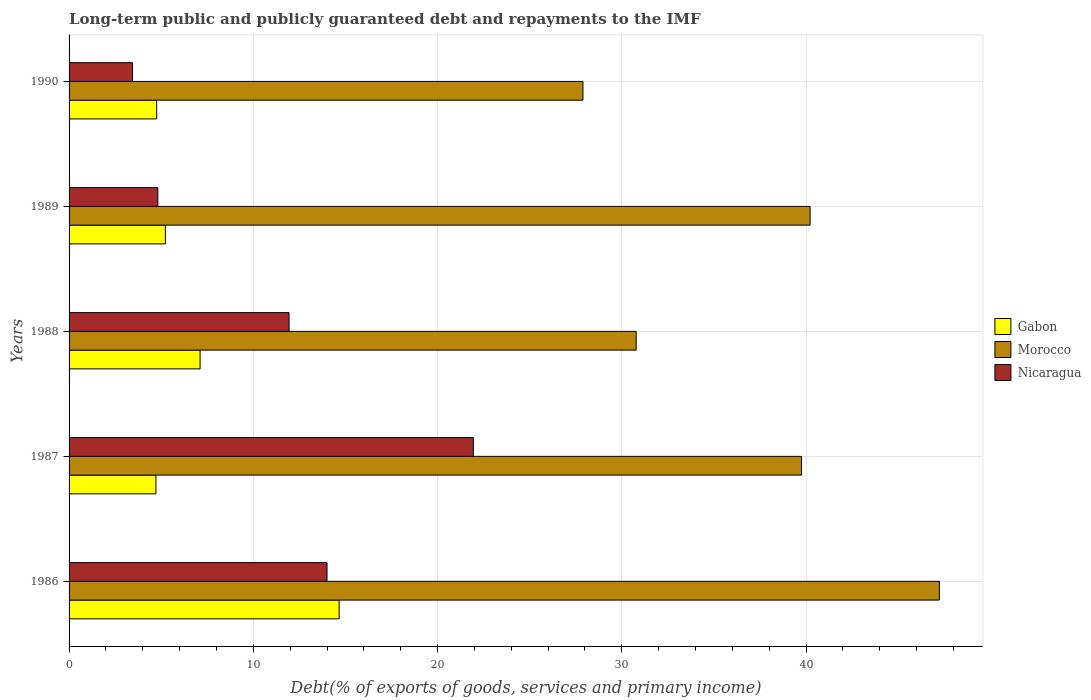How many bars are there on the 3rd tick from the top?
Ensure brevity in your answer.  3. In how many cases, is the number of bars for a given year not equal to the number of legend labels?
Provide a succinct answer. 0. What is the debt and repayments in Morocco in 1988?
Provide a short and direct response. 30.78. Across all years, what is the maximum debt and repayments in Gabon?
Your answer should be very brief. 14.66. Across all years, what is the minimum debt and repayments in Nicaragua?
Your answer should be compact. 3.45. In which year was the debt and repayments in Morocco minimum?
Keep it short and to the point. 1990. What is the total debt and repayments in Morocco in the graph?
Offer a terse response. 185.88. What is the difference between the debt and repayments in Morocco in 1986 and that in 1987?
Provide a short and direct response. 7.48. What is the difference between the debt and repayments in Gabon in 1987 and the debt and repayments in Morocco in 1986?
Your answer should be very brief. -42.52. What is the average debt and repayments in Nicaragua per year?
Offer a terse response. 11.23. In the year 1986, what is the difference between the debt and repayments in Morocco and debt and repayments in Nicaragua?
Offer a very short reply. 33.24. What is the ratio of the debt and repayments in Morocco in 1987 to that in 1988?
Your answer should be very brief. 1.29. Is the debt and repayments in Nicaragua in 1989 less than that in 1990?
Offer a terse response. No. Is the difference between the debt and repayments in Morocco in 1988 and 1990 greater than the difference between the debt and repayments in Nicaragua in 1988 and 1990?
Your response must be concise. No. What is the difference between the highest and the second highest debt and repayments in Morocco?
Your answer should be compact. 7.02. What is the difference between the highest and the lowest debt and repayments in Morocco?
Your answer should be compact. 19.35. What does the 3rd bar from the top in 1989 represents?
Offer a terse response. Gabon. What does the 3rd bar from the bottom in 1990 represents?
Offer a terse response. Nicaragua. How many years are there in the graph?
Make the answer very short. 5. What is the difference between two consecutive major ticks on the X-axis?
Your answer should be compact. 10. Does the graph contain any zero values?
Provide a short and direct response. No. Where does the legend appear in the graph?
Ensure brevity in your answer.  Center right. How many legend labels are there?
Ensure brevity in your answer.  3. What is the title of the graph?
Ensure brevity in your answer.  Long-term public and publicly guaranteed debt and repayments to the IMF. What is the label or title of the X-axis?
Keep it short and to the point. Debt(% of exports of goods, services and primary income). What is the label or title of the Y-axis?
Give a very brief answer. Years. What is the Debt(% of exports of goods, services and primary income) of Gabon in 1986?
Provide a short and direct response. 14.66. What is the Debt(% of exports of goods, services and primary income) in Morocco in 1986?
Offer a very short reply. 47.24. What is the Debt(% of exports of goods, services and primary income) of Gabon in 1987?
Give a very brief answer. 4.72. What is the Debt(% of exports of goods, services and primary income) of Morocco in 1987?
Keep it short and to the point. 39.75. What is the Debt(% of exports of goods, services and primary income) in Nicaragua in 1987?
Your response must be concise. 21.94. What is the Debt(% of exports of goods, services and primary income) of Gabon in 1988?
Keep it short and to the point. 7.11. What is the Debt(% of exports of goods, services and primary income) in Morocco in 1988?
Your response must be concise. 30.78. What is the Debt(% of exports of goods, services and primary income) of Nicaragua in 1988?
Offer a very short reply. 11.94. What is the Debt(% of exports of goods, services and primary income) of Gabon in 1989?
Your answer should be very brief. 5.23. What is the Debt(% of exports of goods, services and primary income) in Morocco in 1989?
Your answer should be very brief. 40.22. What is the Debt(% of exports of goods, services and primary income) in Nicaragua in 1989?
Offer a very short reply. 4.82. What is the Debt(% of exports of goods, services and primary income) of Gabon in 1990?
Provide a short and direct response. 4.76. What is the Debt(% of exports of goods, services and primary income) in Morocco in 1990?
Offer a very short reply. 27.89. What is the Debt(% of exports of goods, services and primary income) in Nicaragua in 1990?
Offer a very short reply. 3.45. Across all years, what is the maximum Debt(% of exports of goods, services and primary income) of Gabon?
Ensure brevity in your answer.  14.66. Across all years, what is the maximum Debt(% of exports of goods, services and primary income) in Morocco?
Your answer should be very brief. 47.24. Across all years, what is the maximum Debt(% of exports of goods, services and primary income) of Nicaragua?
Offer a terse response. 21.94. Across all years, what is the minimum Debt(% of exports of goods, services and primary income) of Gabon?
Provide a short and direct response. 4.72. Across all years, what is the minimum Debt(% of exports of goods, services and primary income) in Morocco?
Keep it short and to the point. 27.89. Across all years, what is the minimum Debt(% of exports of goods, services and primary income) of Nicaragua?
Offer a very short reply. 3.45. What is the total Debt(% of exports of goods, services and primary income) in Gabon in the graph?
Make the answer very short. 36.47. What is the total Debt(% of exports of goods, services and primary income) of Morocco in the graph?
Provide a short and direct response. 185.88. What is the total Debt(% of exports of goods, services and primary income) in Nicaragua in the graph?
Your answer should be very brief. 56.14. What is the difference between the Debt(% of exports of goods, services and primary income) in Gabon in 1986 and that in 1987?
Give a very brief answer. 9.94. What is the difference between the Debt(% of exports of goods, services and primary income) of Morocco in 1986 and that in 1987?
Offer a very short reply. 7.48. What is the difference between the Debt(% of exports of goods, services and primary income) of Nicaragua in 1986 and that in 1987?
Offer a very short reply. -7.94. What is the difference between the Debt(% of exports of goods, services and primary income) in Gabon in 1986 and that in 1988?
Provide a short and direct response. 7.55. What is the difference between the Debt(% of exports of goods, services and primary income) of Morocco in 1986 and that in 1988?
Ensure brevity in your answer.  16.46. What is the difference between the Debt(% of exports of goods, services and primary income) in Nicaragua in 1986 and that in 1988?
Give a very brief answer. 2.06. What is the difference between the Debt(% of exports of goods, services and primary income) of Gabon in 1986 and that in 1989?
Ensure brevity in your answer.  9.43. What is the difference between the Debt(% of exports of goods, services and primary income) of Morocco in 1986 and that in 1989?
Offer a terse response. 7.02. What is the difference between the Debt(% of exports of goods, services and primary income) of Nicaragua in 1986 and that in 1989?
Make the answer very short. 9.18. What is the difference between the Debt(% of exports of goods, services and primary income) of Gabon in 1986 and that in 1990?
Keep it short and to the point. 9.9. What is the difference between the Debt(% of exports of goods, services and primary income) in Morocco in 1986 and that in 1990?
Make the answer very short. 19.35. What is the difference between the Debt(% of exports of goods, services and primary income) of Nicaragua in 1986 and that in 1990?
Your answer should be compact. 10.55. What is the difference between the Debt(% of exports of goods, services and primary income) in Gabon in 1987 and that in 1988?
Your answer should be compact. -2.4. What is the difference between the Debt(% of exports of goods, services and primary income) in Morocco in 1987 and that in 1988?
Keep it short and to the point. 8.97. What is the difference between the Debt(% of exports of goods, services and primary income) in Nicaragua in 1987 and that in 1988?
Offer a terse response. 10. What is the difference between the Debt(% of exports of goods, services and primary income) of Gabon in 1987 and that in 1989?
Make the answer very short. -0.51. What is the difference between the Debt(% of exports of goods, services and primary income) of Morocco in 1987 and that in 1989?
Your answer should be very brief. -0.47. What is the difference between the Debt(% of exports of goods, services and primary income) in Nicaragua in 1987 and that in 1989?
Ensure brevity in your answer.  17.12. What is the difference between the Debt(% of exports of goods, services and primary income) of Gabon in 1987 and that in 1990?
Provide a succinct answer. -0.04. What is the difference between the Debt(% of exports of goods, services and primary income) in Morocco in 1987 and that in 1990?
Make the answer very short. 11.86. What is the difference between the Debt(% of exports of goods, services and primary income) of Nicaragua in 1987 and that in 1990?
Your response must be concise. 18.5. What is the difference between the Debt(% of exports of goods, services and primary income) in Gabon in 1988 and that in 1989?
Your answer should be very brief. 1.88. What is the difference between the Debt(% of exports of goods, services and primary income) of Morocco in 1988 and that in 1989?
Ensure brevity in your answer.  -9.44. What is the difference between the Debt(% of exports of goods, services and primary income) of Nicaragua in 1988 and that in 1989?
Offer a very short reply. 7.12. What is the difference between the Debt(% of exports of goods, services and primary income) of Gabon in 1988 and that in 1990?
Your answer should be compact. 2.36. What is the difference between the Debt(% of exports of goods, services and primary income) of Morocco in 1988 and that in 1990?
Provide a succinct answer. 2.89. What is the difference between the Debt(% of exports of goods, services and primary income) in Nicaragua in 1988 and that in 1990?
Provide a succinct answer. 8.49. What is the difference between the Debt(% of exports of goods, services and primary income) of Gabon in 1989 and that in 1990?
Your response must be concise. 0.47. What is the difference between the Debt(% of exports of goods, services and primary income) of Morocco in 1989 and that in 1990?
Give a very brief answer. 12.33. What is the difference between the Debt(% of exports of goods, services and primary income) in Nicaragua in 1989 and that in 1990?
Keep it short and to the point. 1.37. What is the difference between the Debt(% of exports of goods, services and primary income) in Gabon in 1986 and the Debt(% of exports of goods, services and primary income) in Morocco in 1987?
Keep it short and to the point. -25.1. What is the difference between the Debt(% of exports of goods, services and primary income) of Gabon in 1986 and the Debt(% of exports of goods, services and primary income) of Nicaragua in 1987?
Give a very brief answer. -7.28. What is the difference between the Debt(% of exports of goods, services and primary income) in Morocco in 1986 and the Debt(% of exports of goods, services and primary income) in Nicaragua in 1987?
Offer a terse response. 25.29. What is the difference between the Debt(% of exports of goods, services and primary income) of Gabon in 1986 and the Debt(% of exports of goods, services and primary income) of Morocco in 1988?
Your response must be concise. -16.12. What is the difference between the Debt(% of exports of goods, services and primary income) in Gabon in 1986 and the Debt(% of exports of goods, services and primary income) in Nicaragua in 1988?
Offer a terse response. 2.72. What is the difference between the Debt(% of exports of goods, services and primary income) of Morocco in 1986 and the Debt(% of exports of goods, services and primary income) of Nicaragua in 1988?
Provide a short and direct response. 35.3. What is the difference between the Debt(% of exports of goods, services and primary income) in Gabon in 1986 and the Debt(% of exports of goods, services and primary income) in Morocco in 1989?
Make the answer very short. -25.56. What is the difference between the Debt(% of exports of goods, services and primary income) in Gabon in 1986 and the Debt(% of exports of goods, services and primary income) in Nicaragua in 1989?
Provide a succinct answer. 9.84. What is the difference between the Debt(% of exports of goods, services and primary income) of Morocco in 1986 and the Debt(% of exports of goods, services and primary income) of Nicaragua in 1989?
Your answer should be compact. 42.42. What is the difference between the Debt(% of exports of goods, services and primary income) in Gabon in 1986 and the Debt(% of exports of goods, services and primary income) in Morocco in 1990?
Give a very brief answer. -13.23. What is the difference between the Debt(% of exports of goods, services and primary income) in Gabon in 1986 and the Debt(% of exports of goods, services and primary income) in Nicaragua in 1990?
Offer a terse response. 11.21. What is the difference between the Debt(% of exports of goods, services and primary income) in Morocco in 1986 and the Debt(% of exports of goods, services and primary income) in Nicaragua in 1990?
Your answer should be compact. 43.79. What is the difference between the Debt(% of exports of goods, services and primary income) in Gabon in 1987 and the Debt(% of exports of goods, services and primary income) in Morocco in 1988?
Provide a short and direct response. -26.06. What is the difference between the Debt(% of exports of goods, services and primary income) in Gabon in 1987 and the Debt(% of exports of goods, services and primary income) in Nicaragua in 1988?
Provide a short and direct response. -7.22. What is the difference between the Debt(% of exports of goods, services and primary income) in Morocco in 1987 and the Debt(% of exports of goods, services and primary income) in Nicaragua in 1988?
Your answer should be very brief. 27.81. What is the difference between the Debt(% of exports of goods, services and primary income) in Gabon in 1987 and the Debt(% of exports of goods, services and primary income) in Morocco in 1989?
Ensure brevity in your answer.  -35.51. What is the difference between the Debt(% of exports of goods, services and primary income) of Gabon in 1987 and the Debt(% of exports of goods, services and primary income) of Nicaragua in 1989?
Offer a terse response. -0.1. What is the difference between the Debt(% of exports of goods, services and primary income) of Morocco in 1987 and the Debt(% of exports of goods, services and primary income) of Nicaragua in 1989?
Your answer should be very brief. 34.94. What is the difference between the Debt(% of exports of goods, services and primary income) in Gabon in 1987 and the Debt(% of exports of goods, services and primary income) in Morocco in 1990?
Keep it short and to the point. -23.18. What is the difference between the Debt(% of exports of goods, services and primary income) in Gabon in 1987 and the Debt(% of exports of goods, services and primary income) in Nicaragua in 1990?
Your response must be concise. 1.27. What is the difference between the Debt(% of exports of goods, services and primary income) in Morocco in 1987 and the Debt(% of exports of goods, services and primary income) in Nicaragua in 1990?
Your answer should be compact. 36.31. What is the difference between the Debt(% of exports of goods, services and primary income) in Gabon in 1988 and the Debt(% of exports of goods, services and primary income) in Morocco in 1989?
Provide a succinct answer. -33.11. What is the difference between the Debt(% of exports of goods, services and primary income) in Gabon in 1988 and the Debt(% of exports of goods, services and primary income) in Nicaragua in 1989?
Provide a succinct answer. 2.29. What is the difference between the Debt(% of exports of goods, services and primary income) of Morocco in 1988 and the Debt(% of exports of goods, services and primary income) of Nicaragua in 1989?
Provide a short and direct response. 25.96. What is the difference between the Debt(% of exports of goods, services and primary income) in Gabon in 1988 and the Debt(% of exports of goods, services and primary income) in Morocco in 1990?
Give a very brief answer. -20.78. What is the difference between the Debt(% of exports of goods, services and primary income) of Gabon in 1988 and the Debt(% of exports of goods, services and primary income) of Nicaragua in 1990?
Offer a terse response. 3.67. What is the difference between the Debt(% of exports of goods, services and primary income) in Morocco in 1988 and the Debt(% of exports of goods, services and primary income) in Nicaragua in 1990?
Make the answer very short. 27.33. What is the difference between the Debt(% of exports of goods, services and primary income) in Gabon in 1989 and the Debt(% of exports of goods, services and primary income) in Morocco in 1990?
Provide a short and direct response. -22.66. What is the difference between the Debt(% of exports of goods, services and primary income) of Gabon in 1989 and the Debt(% of exports of goods, services and primary income) of Nicaragua in 1990?
Offer a terse response. 1.78. What is the difference between the Debt(% of exports of goods, services and primary income) in Morocco in 1989 and the Debt(% of exports of goods, services and primary income) in Nicaragua in 1990?
Provide a succinct answer. 36.78. What is the average Debt(% of exports of goods, services and primary income) in Gabon per year?
Your response must be concise. 7.29. What is the average Debt(% of exports of goods, services and primary income) in Morocco per year?
Provide a succinct answer. 37.18. What is the average Debt(% of exports of goods, services and primary income) in Nicaragua per year?
Make the answer very short. 11.23. In the year 1986, what is the difference between the Debt(% of exports of goods, services and primary income) in Gabon and Debt(% of exports of goods, services and primary income) in Morocco?
Your answer should be very brief. -32.58. In the year 1986, what is the difference between the Debt(% of exports of goods, services and primary income) in Gabon and Debt(% of exports of goods, services and primary income) in Nicaragua?
Your response must be concise. 0.66. In the year 1986, what is the difference between the Debt(% of exports of goods, services and primary income) in Morocco and Debt(% of exports of goods, services and primary income) in Nicaragua?
Provide a short and direct response. 33.24. In the year 1987, what is the difference between the Debt(% of exports of goods, services and primary income) of Gabon and Debt(% of exports of goods, services and primary income) of Morocco?
Your response must be concise. -35.04. In the year 1987, what is the difference between the Debt(% of exports of goods, services and primary income) in Gabon and Debt(% of exports of goods, services and primary income) in Nicaragua?
Give a very brief answer. -17.23. In the year 1987, what is the difference between the Debt(% of exports of goods, services and primary income) in Morocco and Debt(% of exports of goods, services and primary income) in Nicaragua?
Provide a short and direct response. 17.81. In the year 1988, what is the difference between the Debt(% of exports of goods, services and primary income) in Gabon and Debt(% of exports of goods, services and primary income) in Morocco?
Your answer should be compact. -23.67. In the year 1988, what is the difference between the Debt(% of exports of goods, services and primary income) in Gabon and Debt(% of exports of goods, services and primary income) in Nicaragua?
Ensure brevity in your answer.  -4.83. In the year 1988, what is the difference between the Debt(% of exports of goods, services and primary income) in Morocco and Debt(% of exports of goods, services and primary income) in Nicaragua?
Provide a succinct answer. 18.84. In the year 1989, what is the difference between the Debt(% of exports of goods, services and primary income) of Gabon and Debt(% of exports of goods, services and primary income) of Morocco?
Offer a very short reply. -34.99. In the year 1989, what is the difference between the Debt(% of exports of goods, services and primary income) of Gabon and Debt(% of exports of goods, services and primary income) of Nicaragua?
Keep it short and to the point. 0.41. In the year 1989, what is the difference between the Debt(% of exports of goods, services and primary income) of Morocco and Debt(% of exports of goods, services and primary income) of Nicaragua?
Ensure brevity in your answer.  35.4. In the year 1990, what is the difference between the Debt(% of exports of goods, services and primary income) of Gabon and Debt(% of exports of goods, services and primary income) of Morocco?
Offer a terse response. -23.14. In the year 1990, what is the difference between the Debt(% of exports of goods, services and primary income) of Gabon and Debt(% of exports of goods, services and primary income) of Nicaragua?
Offer a terse response. 1.31. In the year 1990, what is the difference between the Debt(% of exports of goods, services and primary income) in Morocco and Debt(% of exports of goods, services and primary income) in Nicaragua?
Ensure brevity in your answer.  24.45. What is the ratio of the Debt(% of exports of goods, services and primary income) of Gabon in 1986 to that in 1987?
Offer a very short reply. 3.11. What is the ratio of the Debt(% of exports of goods, services and primary income) in Morocco in 1986 to that in 1987?
Your answer should be compact. 1.19. What is the ratio of the Debt(% of exports of goods, services and primary income) in Nicaragua in 1986 to that in 1987?
Provide a succinct answer. 0.64. What is the ratio of the Debt(% of exports of goods, services and primary income) in Gabon in 1986 to that in 1988?
Make the answer very short. 2.06. What is the ratio of the Debt(% of exports of goods, services and primary income) in Morocco in 1986 to that in 1988?
Give a very brief answer. 1.53. What is the ratio of the Debt(% of exports of goods, services and primary income) in Nicaragua in 1986 to that in 1988?
Your answer should be very brief. 1.17. What is the ratio of the Debt(% of exports of goods, services and primary income) of Gabon in 1986 to that in 1989?
Keep it short and to the point. 2.8. What is the ratio of the Debt(% of exports of goods, services and primary income) in Morocco in 1986 to that in 1989?
Make the answer very short. 1.17. What is the ratio of the Debt(% of exports of goods, services and primary income) in Nicaragua in 1986 to that in 1989?
Offer a terse response. 2.91. What is the ratio of the Debt(% of exports of goods, services and primary income) of Gabon in 1986 to that in 1990?
Give a very brief answer. 3.08. What is the ratio of the Debt(% of exports of goods, services and primary income) in Morocco in 1986 to that in 1990?
Ensure brevity in your answer.  1.69. What is the ratio of the Debt(% of exports of goods, services and primary income) in Nicaragua in 1986 to that in 1990?
Give a very brief answer. 4.06. What is the ratio of the Debt(% of exports of goods, services and primary income) in Gabon in 1987 to that in 1988?
Provide a succinct answer. 0.66. What is the ratio of the Debt(% of exports of goods, services and primary income) of Morocco in 1987 to that in 1988?
Your response must be concise. 1.29. What is the ratio of the Debt(% of exports of goods, services and primary income) of Nicaragua in 1987 to that in 1988?
Ensure brevity in your answer.  1.84. What is the ratio of the Debt(% of exports of goods, services and primary income) of Gabon in 1987 to that in 1989?
Your response must be concise. 0.9. What is the ratio of the Debt(% of exports of goods, services and primary income) in Morocco in 1987 to that in 1989?
Offer a very short reply. 0.99. What is the ratio of the Debt(% of exports of goods, services and primary income) of Nicaragua in 1987 to that in 1989?
Your answer should be compact. 4.55. What is the ratio of the Debt(% of exports of goods, services and primary income) in Morocco in 1987 to that in 1990?
Provide a succinct answer. 1.43. What is the ratio of the Debt(% of exports of goods, services and primary income) in Nicaragua in 1987 to that in 1990?
Ensure brevity in your answer.  6.37. What is the ratio of the Debt(% of exports of goods, services and primary income) in Gabon in 1988 to that in 1989?
Make the answer very short. 1.36. What is the ratio of the Debt(% of exports of goods, services and primary income) of Morocco in 1988 to that in 1989?
Offer a very short reply. 0.77. What is the ratio of the Debt(% of exports of goods, services and primary income) in Nicaragua in 1988 to that in 1989?
Make the answer very short. 2.48. What is the ratio of the Debt(% of exports of goods, services and primary income) of Gabon in 1988 to that in 1990?
Your answer should be very brief. 1.5. What is the ratio of the Debt(% of exports of goods, services and primary income) of Morocco in 1988 to that in 1990?
Make the answer very short. 1.1. What is the ratio of the Debt(% of exports of goods, services and primary income) in Nicaragua in 1988 to that in 1990?
Ensure brevity in your answer.  3.47. What is the ratio of the Debt(% of exports of goods, services and primary income) of Gabon in 1989 to that in 1990?
Your response must be concise. 1.1. What is the ratio of the Debt(% of exports of goods, services and primary income) of Morocco in 1989 to that in 1990?
Provide a succinct answer. 1.44. What is the ratio of the Debt(% of exports of goods, services and primary income) in Nicaragua in 1989 to that in 1990?
Offer a terse response. 1.4. What is the difference between the highest and the second highest Debt(% of exports of goods, services and primary income) of Gabon?
Provide a succinct answer. 7.55. What is the difference between the highest and the second highest Debt(% of exports of goods, services and primary income) in Morocco?
Keep it short and to the point. 7.02. What is the difference between the highest and the second highest Debt(% of exports of goods, services and primary income) in Nicaragua?
Ensure brevity in your answer.  7.94. What is the difference between the highest and the lowest Debt(% of exports of goods, services and primary income) of Gabon?
Give a very brief answer. 9.94. What is the difference between the highest and the lowest Debt(% of exports of goods, services and primary income) in Morocco?
Make the answer very short. 19.35. What is the difference between the highest and the lowest Debt(% of exports of goods, services and primary income) in Nicaragua?
Provide a succinct answer. 18.5. 